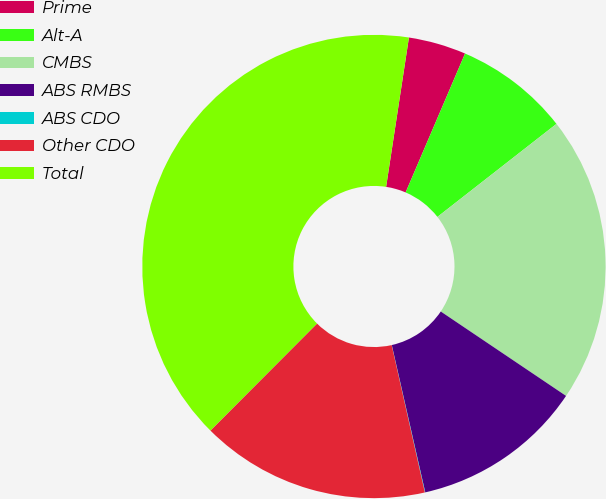Convert chart. <chart><loc_0><loc_0><loc_500><loc_500><pie_chart><fcel>Prime<fcel>Alt-A<fcel>CMBS<fcel>ABS RMBS<fcel>ABS CDO<fcel>Other CDO<fcel>Total<nl><fcel>4.02%<fcel>8.01%<fcel>19.99%<fcel>12.01%<fcel>0.03%<fcel>16.0%<fcel>39.94%<nl></chart> 